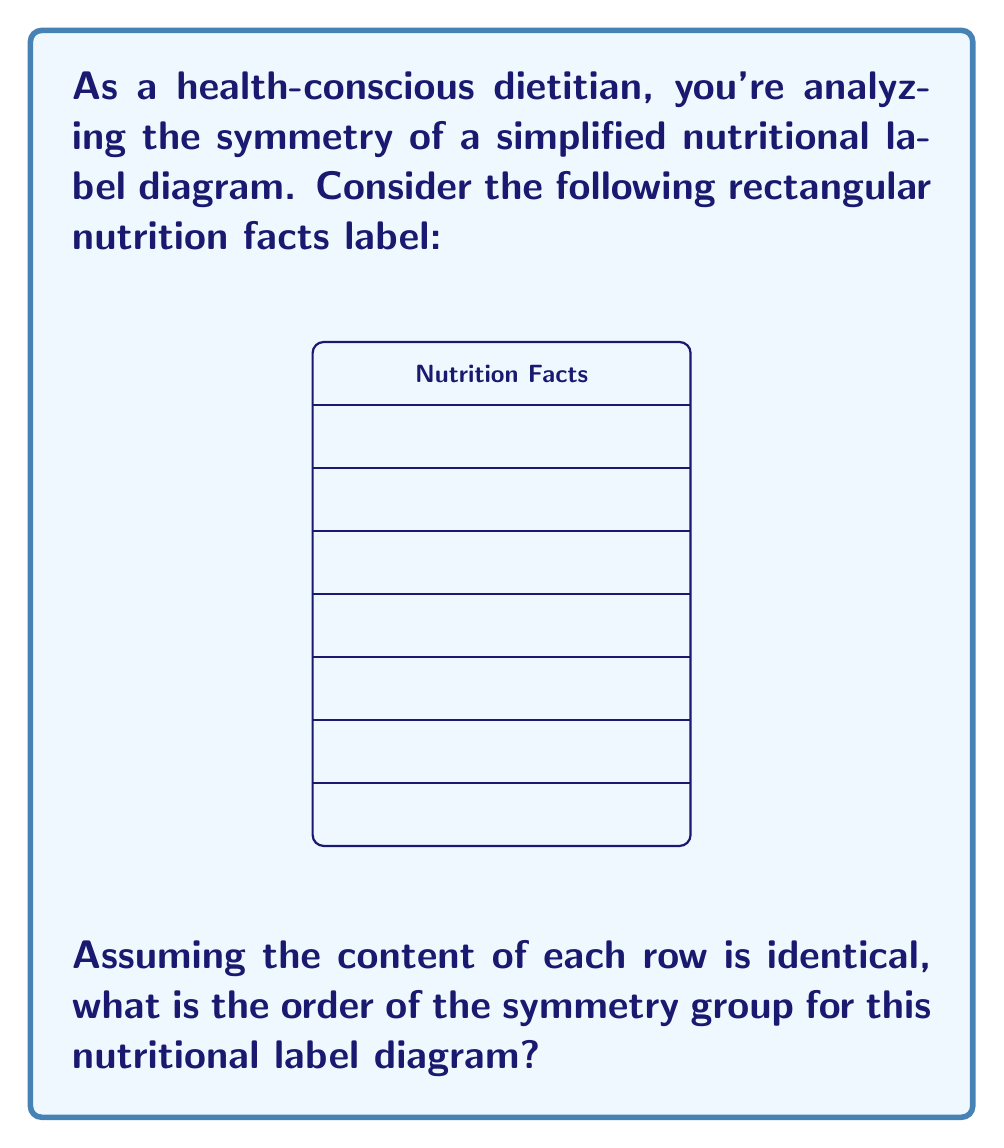Can you solve this math problem? To find the order of the symmetry group for this nutritional label diagram, we need to consider all the possible symmetry operations that leave the diagram unchanged. Let's analyze step-by-step:

1) Rotational symmetry:
   - The diagram has 2-fold rotational symmetry (180° rotation).
   - There are 2 distinct rotations: 0° (identity) and 180°.

2) Reflection symmetry:
   - Vertical reflection through the center.
   - Horizontal reflection through the middle.

3) Total symmetry operations:
   - Identity (do nothing)
   - 180° rotation
   - Vertical reflection
   - Horizontal reflection

These four operations form the symmetry group of the rectangle, which is known as the Klein four-group or $V_4$.

The order of a group is the number of elements in the group. In this case, we have identified 4 distinct symmetry operations.

Therefore, the order of the symmetry group for this nutritional label diagram is 4.

Note: This assumes that the content of each row is identical and that the "Nutrition Facts" text at the top is centered. If the content were different in each row or the text were not centered, it would affect the symmetry group.
Answer: 4 